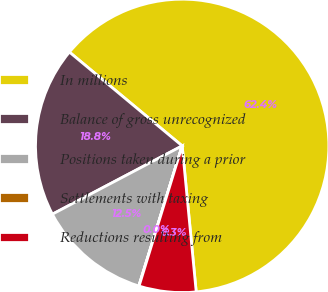Convert chart to OTSL. <chart><loc_0><loc_0><loc_500><loc_500><pie_chart><fcel>In millions<fcel>Balance of gross unrecognized<fcel>Positions taken during a prior<fcel>Settlements with taxing<fcel>Reductions resulting from<nl><fcel>62.43%<fcel>18.75%<fcel>12.51%<fcel>0.03%<fcel>6.27%<nl></chart> 